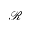<formula> <loc_0><loc_0><loc_500><loc_500>\mathcal { R }</formula> 